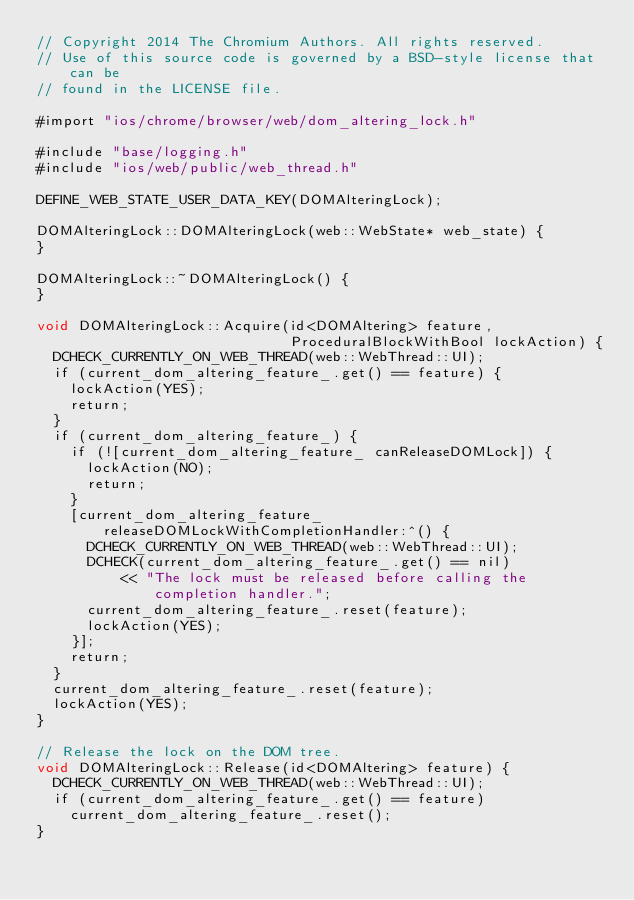Convert code to text. <code><loc_0><loc_0><loc_500><loc_500><_ObjectiveC_>// Copyright 2014 The Chromium Authors. All rights reserved.
// Use of this source code is governed by a BSD-style license that can be
// found in the LICENSE file.

#import "ios/chrome/browser/web/dom_altering_lock.h"

#include "base/logging.h"
#include "ios/web/public/web_thread.h"

DEFINE_WEB_STATE_USER_DATA_KEY(DOMAlteringLock);

DOMAlteringLock::DOMAlteringLock(web::WebState* web_state) {
}

DOMAlteringLock::~DOMAlteringLock() {
}

void DOMAlteringLock::Acquire(id<DOMAltering> feature,
                              ProceduralBlockWithBool lockAction) {
  DCHECK_CURRENTLY_ON_WEB_THREAD(web::WebThread::UI);
  if (current_dom_altering_feature_.get() == feature) {
    lockAction(YES);
    return;
  }
  if (current_dom_altering_feature_) {
    if (![current_dom_altering_feature_ canReleaseDOMLock]) {
      lockAction(NO);
      return;
    }
    [current_dom_altering_feature_ releaseDOMLockWithCompletionHandler:^() {
      DCHECK_CURRENTLY_ON_WEB_THREAD(web::WebThread::UI);
      DCHECK(current_dom_altering_feature_.get() == nil)
          << "The lock must be released before calling the completion handler.";
      current_dom_altering_feature_.reset(feature);
      lockAction(YES);
    }];
    return;
  }
  current_dom_altering_feature_.reset(feature);
  lockAction(YES);
}

// Release the lock on the DOM tree.
void DOMAlteringLock::Release(id<DOMAltering> feature) {
  DCHECK_CURRENTLY_ON_WEB_THREAD(web::WebThread::UI);
  if (current_dom_altering_feature_.get() == feature)
    current_dom_altering_feature_.reset();
}
</code> 